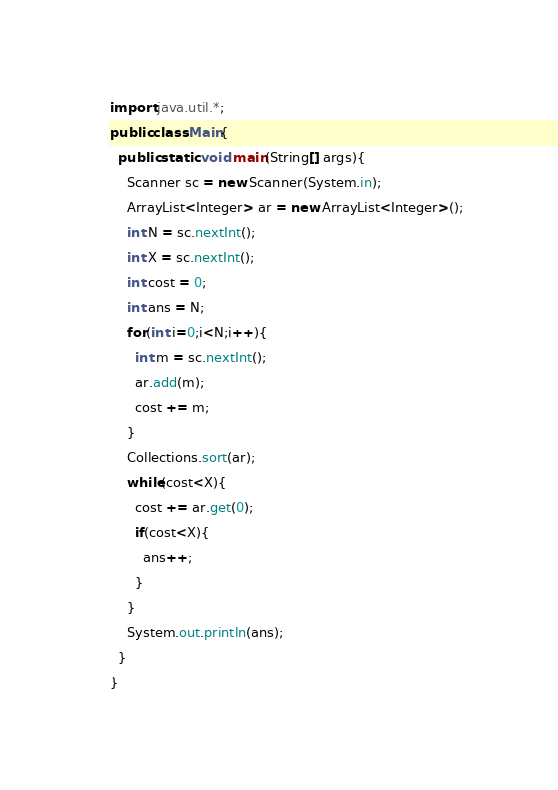<code> <loc_0><loc_0><loc_500><loc_500><_Java_>import java.util.*;
public class Main{
  public static void main(String[] args){
    Scanner sc = new Scanner(System.in);
    ArrayList<Integer> ar = new ArrayList<Integer>();
    int N = sc.nextInt();
    int X = sc.nextInt();
    int cost = 0;
    int ans = N;
    for(int i=0;i<N;i++){
      int m = sc.nextInt();
      ar.add(m);
      cost += m;
    }
    Collections.sort(ar);
    while(cost<X){
      cost += ar.get(0);
      if(cost<X){
        ans++;
      }
    }
    System.out.println(ans);
  }
}
</code> 